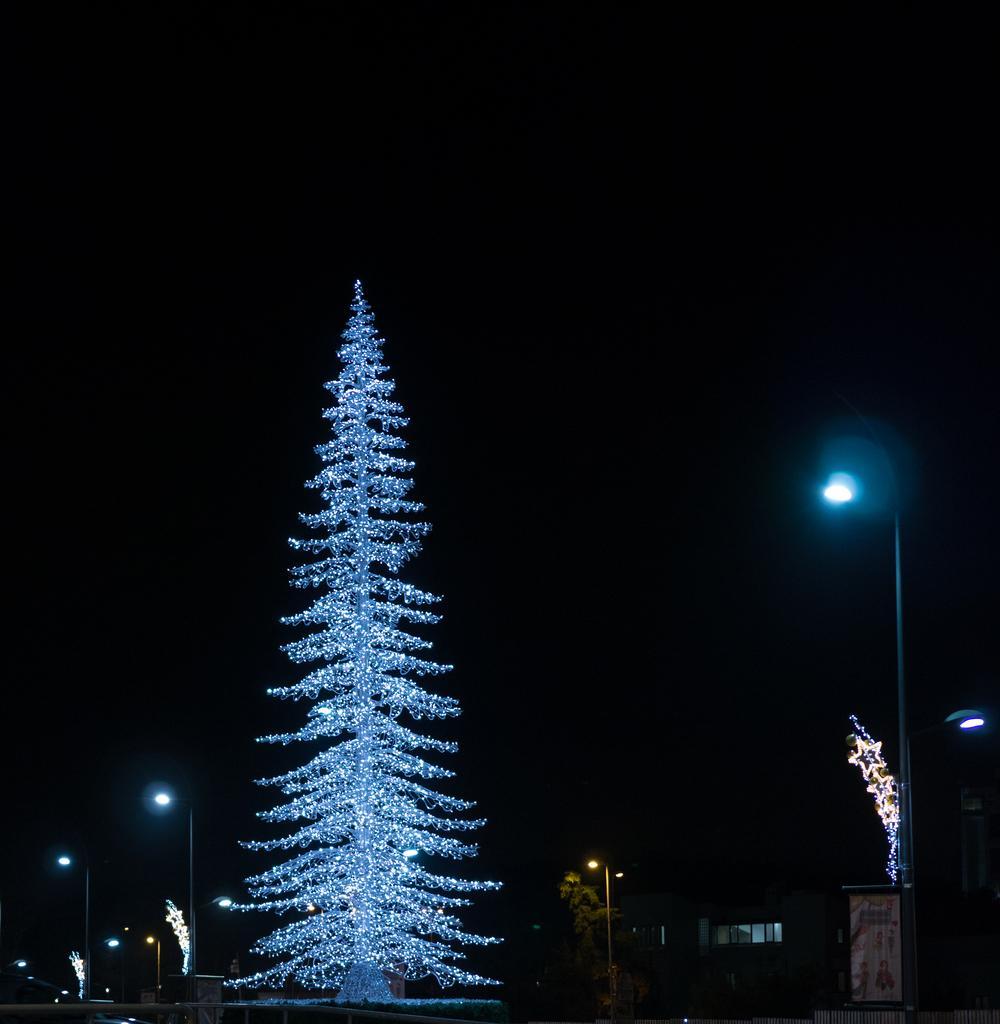Describe this image in one or two sentences. In this picture there is a christmas tree on the left side of the image and there is a pole on the right side of the image. 